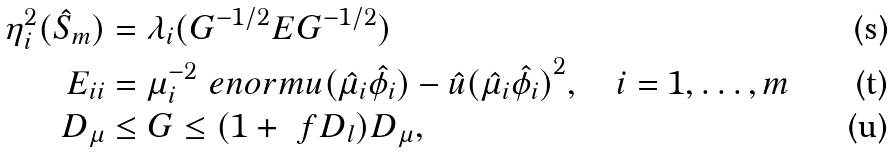<formula> <loc_0><loc_0><loc_500><loc_500>\eta _ { i } ^ { 2 } ( \hat { S } _ { m } ) & = \lambda _ { i } ( G ^ { - 1 / 2 } E G ^ { - 1 / 2 } ) \\ E _ { i i } & = \mu _ { i } ^ { - 2 } \ e n o r m { u ( \hat { \mu } _ { i } \hat { \phi } _ { i } ) - \hat { u } ( \hat { \mu } _ { i } \hat { \phi } _ { i } ) } ^ { 2 } , \quad i = 1 , \dots , m \\ D _ { \mu } & \leq G \leq ( 1 + \ f D _ { l } ) D _ { \mu } ,</formula> 